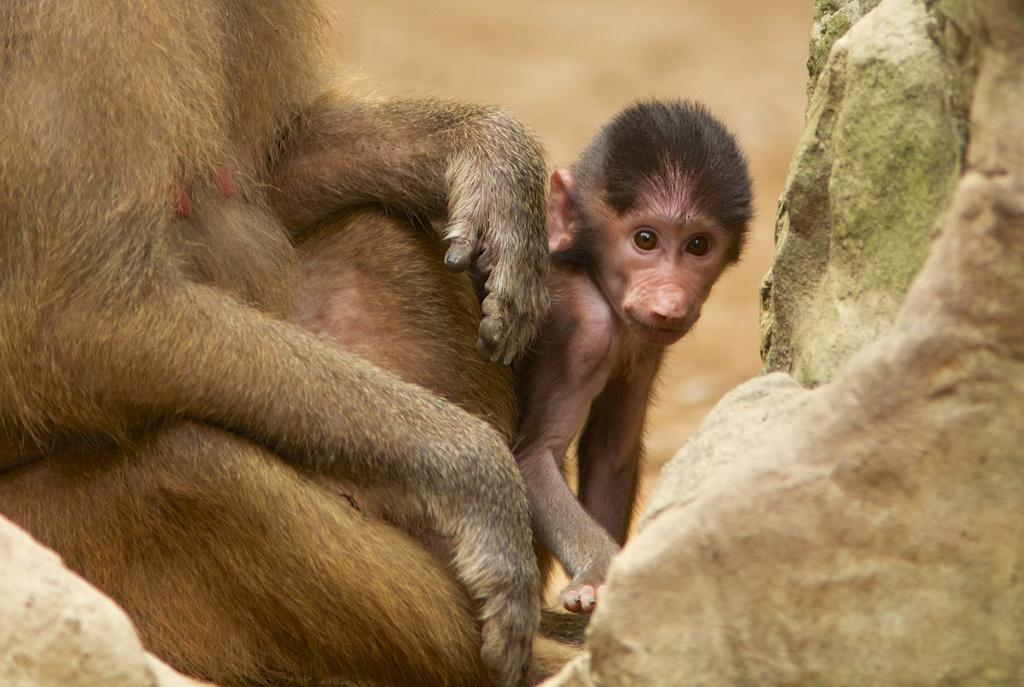What type of animals are present in the image? There are monkeys in the image. What else can be seen in the image besides the monkeys? There are rocks in the image. Can you describe the background of the image? The background of the image is blurry. How many books can be seen on the railway in the image? A: There are no books or railway present in the image; it features monkeys and rocks. 